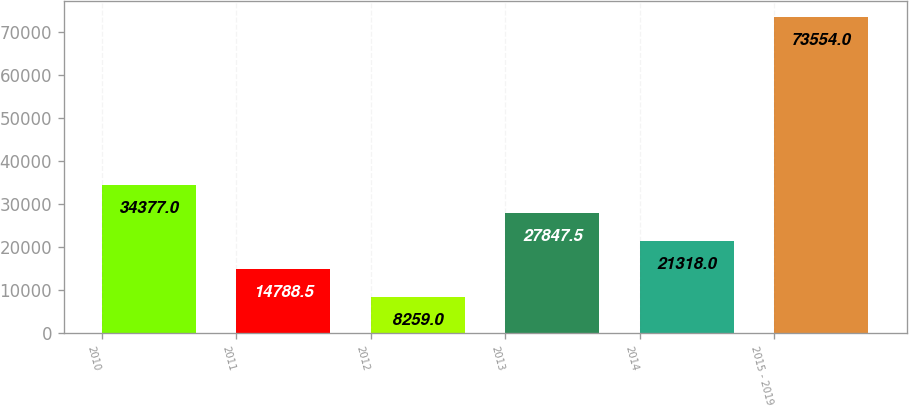<chart> <loc_0><loc_0><loc_500><loc_500><bar_chart><fcel>2010<fcel>2011<fcel>2012<fcel>2013<fcel>2014<fcel>2015 - 2019<nl><fcel>34377<fcel>14788.5<fcel>8259<fcel>27847.5<fcel>21318<fcel>73554<nl></chart> 